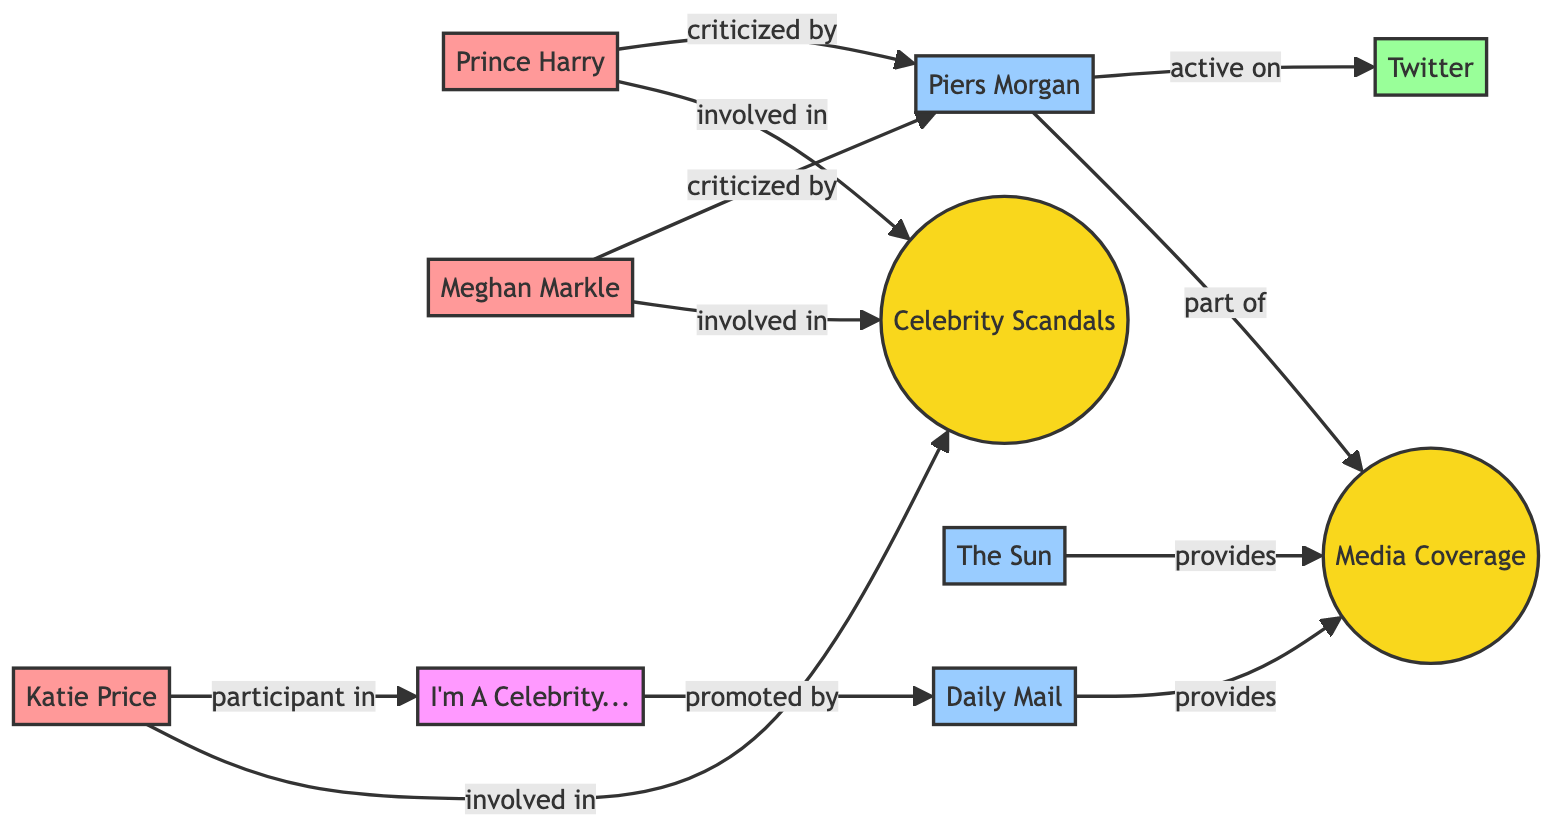What celebrity is criticized by Piers Morgan? By inspecting the connections, both Prince Harry and Meghan Markle have arrows leading to Piers Morgan with the label "criticized by". Thus, both celebrities are noted to be criticized by him.
Answer: Prince Harry, Meghan Markle How many media outlets are connected to media coverage? In the diagram, we can see both The Sun and Daily Mail connected to Media Coverage, as indicated by the edges labeled "provides". Therefore, we count a total of two media outlets.
Answer: 2 Which social media platform is mentioned as being used by Piers Morgan? The diagram shows an edge from Piers Morgan to Twitter with the label "active on", indicating that he actively uses this social media platform.
Answer: Twitter Who is involved in celebrity scandals? The connections show that Prince Harry, Meghan Markle, and Katie Price are linked to "Celebrity Scandals" with the label "involved in". Therefore, the answer includes all three celebrities.
Answer: Prince Harry, Meghan Markle, Katie Price What is promoted by the Daily Mail? The diagram does not show any direct connection from Daily Mail to other nodes. Instead, it connects to Media Coverage, implying it primarily works to provide media coverage rather than promoting anything directly. As such, the answer is that it does not promote anything directly.
Answer: None 